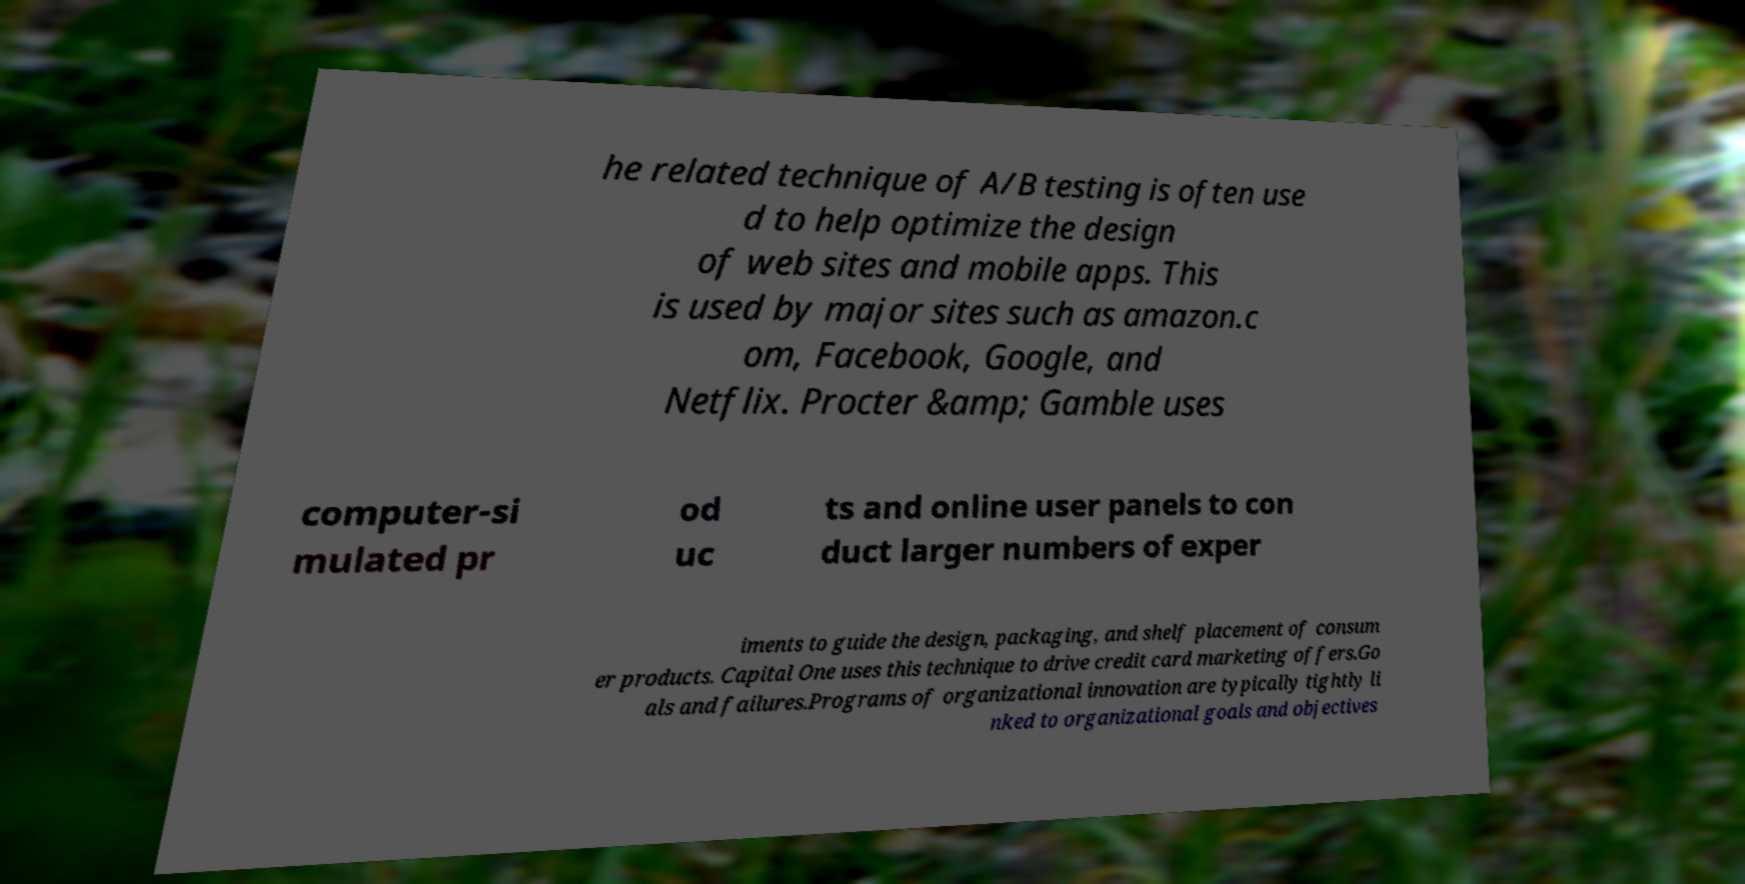Can you accurately transcribe the text from the provided image for me? he related technique of A/B testing is often use d to help optimize the design of web sites and mobile apps. This is used by major sites such as amazon.c om, Facebook, Google, and Netflix. Procter &amp; Gamble uses computer-si mulated pr od uc ts and online user panels to con duct larger numbers of exper iments to guide the design, packaging, and shelf placement of consum er products. Capital One uses this technique to drive credit card marketing offers.Go als and failures.Programs of organizational innovation are typically tightly li nked to organizational goals and objectives 